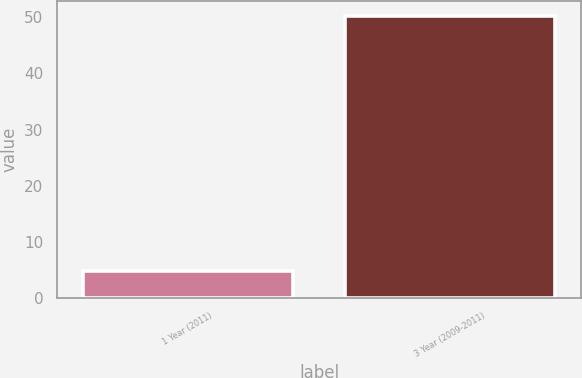Convert chart to OTSL. <chart><loc_0><loc_0><loc_500><loc_500><bar_chart><fcel>1 Year (2011)<fcel>3 Year (2009-2011)<nl><fcel>4.84<fcel>50.3<nl></chart> 